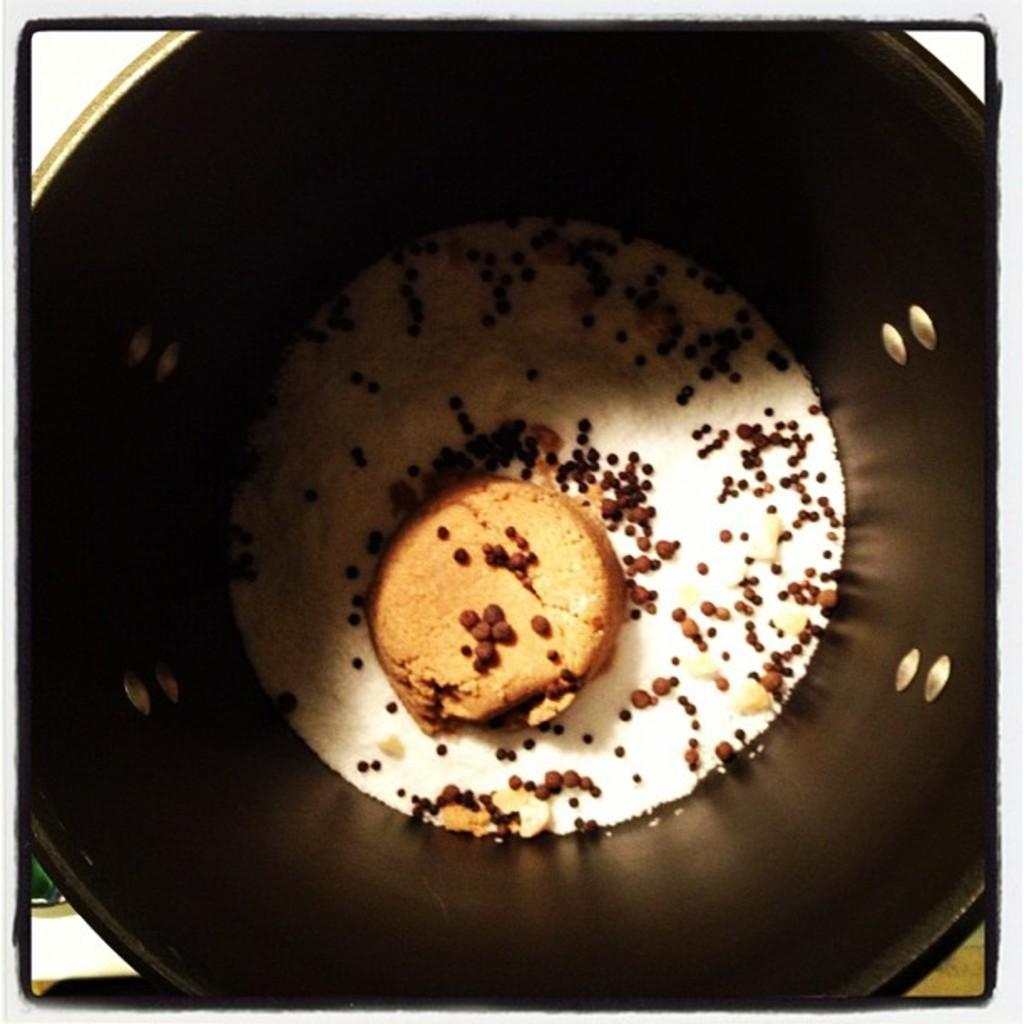What is the main object in the image? There is a biscuit in the image. What else can be seen in the image besides the biscuit? There are other ingredients in the image. How are the ingredients arranged in the image? The ingredients are in a bucket. What is the color of the background in the image? The background of the image is white. How many spiders are crawling on the man in the image? There is no man or spiders present in the image. What type of reaction can be seen from the man in the image? There is no man present in the image, so no reaction can be observed. 